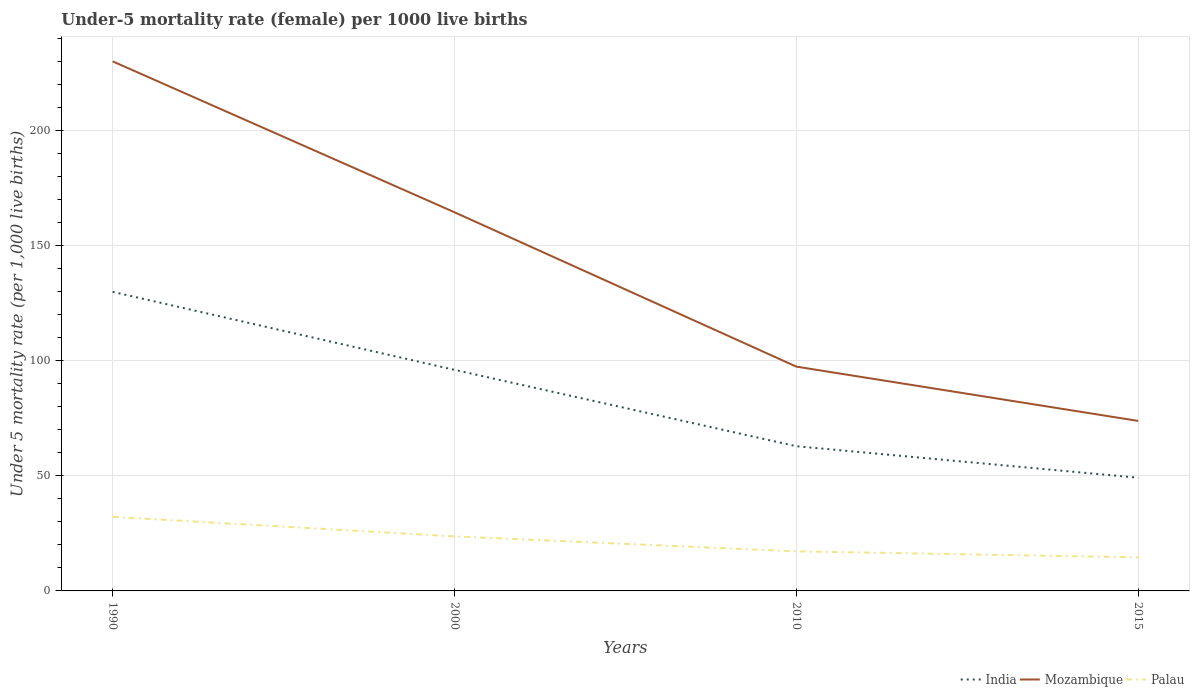Across all years, what is the maximum under-five mortality rate in Palau?
Offer a terse response. 14.6. In which year was the under-five mortality rate in India maximum?
Offer a very short reply. 2015. What is the total under-five mortality rate in Mozambique in the graph?
Provide a succinct answer. 90.7. What is the difference between the highest and the second highest under-five mortality rate in Mozambique?
Offer a very short reply. 156.3. How many years are there in the graph?
Your answer should be very brief. 4. Does the graph contain any zero values?
Your answer should be very brief. No. Where does the legend appear in the graph?
Your response must be concise. Bottom right. What is the title of the graph?
Your answer should be compact. Under-5 mortality rate (female) per 1000 live births. What is the label or title of the Y-axis?
Your response must be concise. Under 5 mortality rate (per 1,0 live births). What is the Under 5 mortality rate (per 1,000 live births) of India in 1990?
Your response must be concise. 130. What is the Under 5 mortality rate (per 1,000 live births) of Mozambique in 1990?
Provide a short and direct response. 230.2. What is the Under 5 mortality rate (per 1,000 live births) of Palau in 1990?
Ensure brevity in your answer.  32.2. What is the Under 5 mortality rate (per 1,000 live births) of India in 2000?
Make the answer very short. 96.1. What is the Under 5 mortality rate (per 1,000 live births) of Mozambique in 2000?
Your answer should be compact. 164.6. What is the Under 5 mortality rate (per 1,000 live births) in Palau in 2000?
Offer a terse response. 23.7. What is the Under 5 mortality rate (per 1,000 live births) of India in 2010?
Give a very brief answer. 62.9. What is the Under 5 mortality rate (per 1,000 live births) in Mozambique in 2010?
Your response must be concise. 97.5. What is the Under 5 mortality rate (per 1,000 live births) of India in 2015?
Offer a very short reply. 49.2. What is the Under 5 mortality rate (per 1,000 live births) of Mozambique in 2015?
Offer a terse response. 73.9. What is the Under 5 mortality rate (per 1,000 live births) of Palau in 2015?
Your answer should be compact. 14.6. Across all years, what is the maximum Under 5 mortality rate (per 1,000 live births) of India?
Make the answer very short. 130. Across all years, what is the maximum Under 5 mortality rate (per 1,000 live births) in Mozambique?
Keep it short and to the point. 230.2. Across all years, what is the maximum Under 5 mortality rate (per 1,000 live births) of Palau?
Your answer should be very brief. 32.2. Across all years, what is the minimum Under 5 mortality rate (per 1,000 live births) in India?
Give a very brief answer. 49.2. Across all years, what is the minimum Under 5 mortality rate (per 1,000 live births) of Mozambique?
Your answer should be very brief. 73.9. Across all years, what is the minimum Under 5 mortality rate (per 1,000 live births) of Palau?
Your response must be concise. 14.6. What is the total Under 5 mortality rate (per 1,000 live births) of India in the graph?
Offer a very short reply. 338.2. What is the total Under 5 mortality rate (per 1,000 live births) of Mozambique in the graph?
Your answer should be very brief. 566.2. What is the total Under 5 mortality rate (per 1,000 live births) of Palau in the graph?
Your answer should be compact. 87.7. What is the difference between the Under 5 mortality rate (per 1,000 live births) in India in 1990 and that in 2000?
Your response must be concise. 33.9. What is the difference between the Under 5 mortality rate (per 1,000 live births) of Mozambique in 1990 and that in 2000?
Offer a terse response. 65.6. What is the difference between the Under 5 mortality rate (per 1,000 live births) in Palau in 1990 and that in 2000?
Provide a short and direct response. 8.5. What is the difference between the Under 5 mortality rate (per 1,000 live births) in India in 1990 and that in 2010?
Your response must be concise. 67.1. What is the difference between the Under 5 mortality rate (per 1,000 live births) in Mozambique in 1990 and that in 2010?
Provide a short and direct response. 132.7. What is the difference between the Under 5 mortality rate (per 1,000 live births) in India in 1990 and that in 2015?
Offer a terse response. 80.8. What is the difference between the Under 5 mortality rate (per 1,000 live births) of Mozambique in 1990 and that in 2015?
Offer a terse response. 156.3. What is the difference between the Under 5 mortality rate (per 1,000 live births) of India in 2000 and that in 2010?
Your answer should be very brief. 33.2. What is the difference between the Under 5 mortality rate (per 1,000 live births) in Mozambique in 2000 and that in 2010?
Your response must be concise. 67.1. What is the difference between the Under 5 mortality rate (per 1,000 live births) of India in 2000 and that in 2015?
Offer a terse response. 46.9. What is the difference between the Under 5 mortality rate (per 1,000 live births) of Mozambique in 2000 and that in 2015?
Provide a short and direct response. 90.7. What is the difference between the Under 5 mortality rate (per 1,000 live births) of Palau in 2000 and that in 2015?
Your response must be concise. 9.1. What is the difference between the Under 5 mortality rate (per 1,000 live births) in Mozambique in 2010 and that in 2015?
Your response must be concise. 23.6. What is the difference between the Under 5 mortality rate (per 1,000 live births) in Palau in 2010 and that in 2015?
Offer a terse response. 2.6. What is the difference between the Under 5 mortality rate (per 1,000 live births) of India in 1990 and the Under 5 mortality rate (per 1,000 live births) of Mozambique in 2000?
Offer a terse response. -34.6. What is the difference between the Under 5 mortality rate (per 1,000 live births) of India in 1990 and the Under 5 mortality rate (per 1,000 live births) of Palau in 2000?
Offer a very short reply. 106.3. What is the difference between the Under 5 mortality rate (per 1,000 live births) of Mozambique in 1990 and the Under 5 mortality rate (per 1,000 live births) of Palau in 2000?
Provide a short and direct response. 206.5. What is the difference between the Under 5 mortality rate (per 1,000 live births) of India in 1990 and the Under 5 mortality rate (per 1,000 live births) of Mozambique in 2010?
Give a very brief answer. 32.5. What is the difference between the Under 5 mortality rate (per 1,000 live births) of India in 1990 and the Under 5 mortality rate (per 1,000 live births) of Palau in 2010?
Give a very brief answer. 112.8. What is the difference between the Under 5 mortality rate (per 1,000 live births) in Mozambique in 1990 and the Under 5 mortality rate (per 1,000 live births) in Palau in 2010?
Keep it short and to the point. 213. What is the difference between the Under 5 mortality rate (per 1,000 live births) in India in 1990 and the Under 5 mortality rate (per 1,000 live births) in Mozambique in 2015?
Offer a terse response. 56.1. What is the difference between the Under 5 mortality rate (per 1,000 live births) of India in 1990 and the Under 5 mortality rate (per 1,000 live births) of Palau in 2015?
Provide a succinct answer. 115.4. What is the difference between the Under 5 mortality rate (per 1,000 live births) in Mozambique in 1990 and the Under 5 mortality rate (per 1,000 live births) in Palau in 2015?
Your response must be concise. 215.6. What is the difference between the Under 5 mortality rate (per 1,000 live births) of India in 2000 and the Under 5 mortality rate (per 1,000 live births) of Palau in 2010?
Provide a succinct answer. 78.9. What is the difference between the Under 5 mortality rate (per 1,000 live births) in Mozambique in 2000 and the Under 5 mortality rate (per 1,000 live births) in Palau in 2010?
Your answer should be compact. 147.4. What is the difference between the Under 5 mortality rate (per 1,000 live births) in India in 2000 and the Under 5 mortality rate (per 1,000 live births) in Palau in 2015?
Provide a succinct answer. 81.5. What is the difference between the Under 5 mortality rate (per 1,000 live births) in Mozambique in 2000 and the Under 5 mortality rate (per 1,000 live births) in Palau in 2015?
Ensure brevity in your answer.  150. What is the difference between the Under 5 mortality rate (per 1,000 live births) of India in 2010 and the Under 5 mortality rate (per 1,000 live births) of Mozambique in 2015?
Make the answer very short. -11. What is the difference between the Under 5 mortality rate (per 1,000 live births) in India in 2010 and the Under 5 mortality rate (per 1,000 live births) in Palau in 2015?
Your response must be concise. 48.3. What is the difference between the Under 5 mortality rate (per 1,000 live births) in Mozambique in 2010 and the Under 5 mortality rate (per 1,000 live births) in Palau in 2015?
Your response must be concise. 82.9. What is the average Under 5 mortality rate (per 1,000 live births) in India per year?
Offer a very short reply. 84.55. What is the average Under 5 mortality rate (per 1,000 live births) in Mozambique per year?
Your response must be concise. 141.55. What is the average Under 5 mortality rate (per 1,000 live births) of Palau per year?
Make the answer very short. 21.93. In the year 1990, what is the difference between the Under 5 mortality rate (per 1,000 live births) of India and Under 5 mortality rate (per 1,000 live births) of Mozambique?
Provide a short and direct response. -100.2. In the year 1990, what is the difference between the Under 5 mortality rate (per 1,000 live births) in India and Under 5 mortality rate (per 1,000 live births) in Palau?
Provide a short and direct response. 97.8. In the year 1990, what is the difference between the Under 5 mortality rate (per 1,000 live births) in Mozambique and Under 5 mortality rate (per 1,000 live births) in Palau?
Provide a short and direct response. 198. In the year 2000, what is the difference between the Under 5 mortality rate (per 1,000 live births) in India and Under 5 mortality rate (per 1,000 live births) in Mozambique?
Give a very brief answer. -68.5. In the year 2000, what is the difference between the Under 5 mortality rate (per 1,000 live births) of India and Under 5 mortality rate (per 1,000 live births) of Palau?
Offer a very short reply. 72.4. In the year 2000, what is the difference between the Under 5 mortality rate (per 1,000 live births) in Mozambique and Under 5 mortality rate (per 1,000 live births) in Palau?
Your answer should be very brief. 140.9. In the year 2010, what is the difference between the Under 5 mortality rate (per 1,000 live births) in India and Under 5 mortality rate (per 1,000 live births) in Mozambique?
Your answer should be very brief. -34.6. In the year 2010, what is the difference between the Under 5 mortality rate (per 1,000 live births) in India and Under 5 mortality rate (per 1,000 live births) in Palau?
Offer a terse response. 45.7. In the year 2010, what is the difference between the Under 5 mortality rate (per 1,000 live births) of Mozambique and Under 5 mortality rate (per 1,000 live births) of Palau?
Your answer should be very brief. 80.3. In the year 2015, what is the difference between the Under 5 mortality rate (per 1,000 live births) in India and Under 5 mortality rate (per 1,000 live births) in Mozambique?
Ensure brevity in your answer.  -24.7. In the year 2015, what is the difference between the Under 5 mortality rate (per 1,000 live births) of India and Under 5 mortality rate (per 1,000 live births) of Palau?
Provide a short and direct response. 34.6. In the year 2015, what is the difference between the Under 5 mortality rate (per 1,000 live births) in Mozambique and Under 5 mortality rate (per 1,000 live births) in Palau?
Provide a succinct answer. 59.3. What is the ratio of the Under 5 mortality rate (per 1,000 live births) of India in 1990 to that in 2000?
Keep it short and to the point. 1.35. What is the ratio of the Under 5 mortality rate (per 1,000 live births) in Mozambique in 1990 to that in 2000?
Your answer should be very brief. 1.4. What is the ratio of the Under 5 mortality rate (per 1,000 live births) of Palau in 1990 to that in 2000?
Your response must be concise. 1.36. What is the ratio of the Under 5 mortality rate (per 1,000 live births) in India in 1990 to that in 2010?
Your response must be concise. 2.07. What is the ratio of the Under 5 mortality rate (per 1,000 live births) in Mozambique in 1990 to that in 2010?
Provide a short and direct response. 2.36. What is the ratio of the Under 5 mortality rate (per 1,000 live births) in Palau in 1990 to that in 2010?
Make the answer very short. 1.87. What is the ratio of the Under 5 mortality rate (per 1,000 live births) of India in 1990 to that in 2015?
Offer a very short reply. 2.64. What is the ratio of the Under 5 mortality rate (per 1,000 live births) of Mozambique in 1990 to that in 2015?
Keep it short and to the point. 3.12. What is the ratio of the Under 5 mortality rate (per 1,000 live births) in Palau in 1990 to that in 2015?
Your response must be concise. 2.21. What is the ratio of the Under 5 mortality rate (per 1,000 live births) in India in 2000 to that in 2010?
Offer a very short reply. 1.53. What is the ratio of the Under 5 mortality rate (per 1,000 live births) in Mozambique in 2000 to that in 2010?
Your answer should be compact. 1.69. What is the ratio of the Under 5 mortality rate (per 1,000 live births) of Palau in 2000 to that in 2010?
Offer a very short reply. 1.38. What is the ratio of the Under 5 mortality rate (per 1,000 live births) in India in 2000 to that in 2015?
Your answer should be very brief. 1.95. What is the ratio of the Under 5 mortality rate (per 1,000 live births) in Mozambique in 2000 to that in 2015?
Provide a succinct answer. 2.23. What is the ratio of the Under 5 mortality rate (per 1,000 live births) in Palau in 2000 to that in 2015?
Provide a succinct answer. 1.62. What is the ratio of the Under 5 mortality rate (per 1,000 live births) in India in 2010 to that in 2015?
Provide a short and direct response. 1.28. What is the ratio of the Under 5 mortality rate (per 1,000 live births) in Mozambique in 2010 to that in 2015?
Offer a very short reply. 1.32. What is the ratio of the Under 5 mortality rate (per 1,000 live births) in Palau in 2010 to that in 2015?
Your answer should be very brief. 1.18. What is the difference between the highest and the second highest Under 5 mortality rate (per 1,000 live births) of India?
Your answer should be compact. 33.9. What is the difference between the highest and the second highest Under 5 mortality rate (per 1,000 live births) in Mozambique?
Offer a terse response. 65.6. What is the difference between the highest and the second highest Under 5 mortality rate (per 1,000 live births) in Palau?
Offer a terse response. 8.5. What is the difference between the highest and the lowest Under 5 mortality rate (per 1,000 live births) in India?
Ensure brevity in your answer.  80.8. What is the difference between the highest and the lowest Under 5 mortality rate (per 1,000 live births) of Mozambique?
Keep it short and to the point. 156.3. What is the difference between the highest and the lowest Under 5 mortality rate (per 1,000 live births) of Palau?
Give a very brief answer. 17.6. 